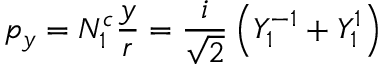<formula> <loc_0><loc_0><loc_500><loc_500>p _ { y } = N _ { 1 } ^ { c } { \frac { y } { r } } = { \frac { i } { \sqrt { 2 } } } \left ( Y _ { 1 } ^ { - 1 } + Y _ { 1 } ^ { 1 } \right )</formula> 